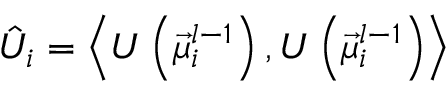<formula> <loc_0><loc_0><loc_500><loc_500>\hat { U } _ { i } = \left \langle U \left ( \vec { \mu } _ { i } ^ { l - 1 } \right ) , U \left ( \vec { \mu } _ { i } ^ { l - 1 } \right ) \right \rangle</formula> 